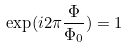Convert formula to latex. <formula><loc_0><loc_0><loc_500><loc_500>\exp ( i 2 \pi \frac { \Phi } { \Phi _ { 0 } } ) = 1</formula> 